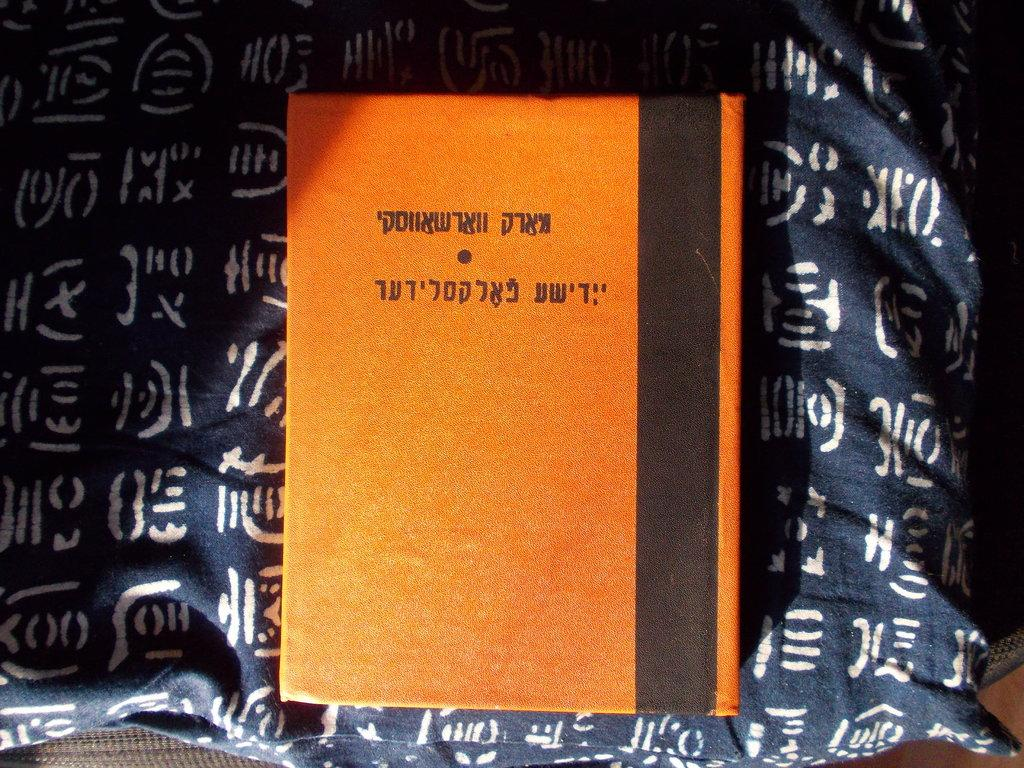What type of book is visible in the image? There is an orange and black color book in the image. What is the book placed on? The book is on a white and navy-blue color cloth. Where is the basin located in the image? There is no basin present in the image. Can you see a stream in the image? There is no stream visible in the image. 